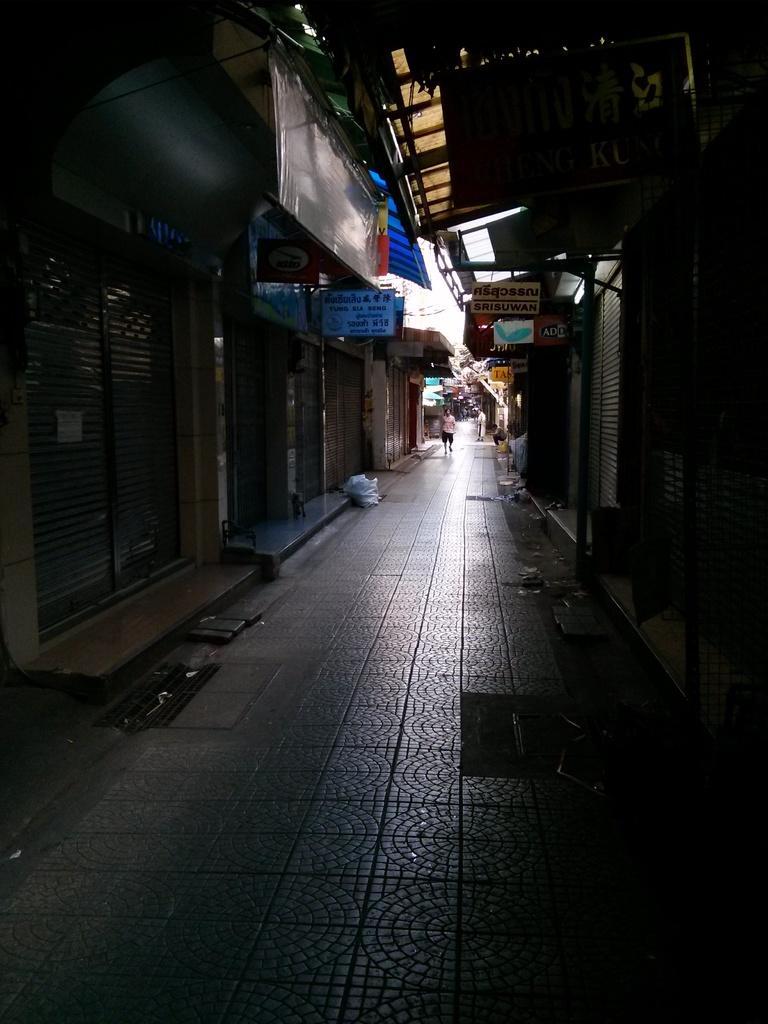Describe this image in one or two sentences. In this image there is a road beside that there are so many buildings and also there is a person walking from the middle. 